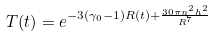Convert formula to latex. <formula><loc_0><loc_0><loc_500><loc_500>T ( t ) = e ^ { - 3 ( { \gamma } _ { 0 } - 1 ) R ( t ) + \frac { 3 0 { \pi } n ^ { 2 } h ^ { 2 } } { R ^ { 7 } } }</formula> 